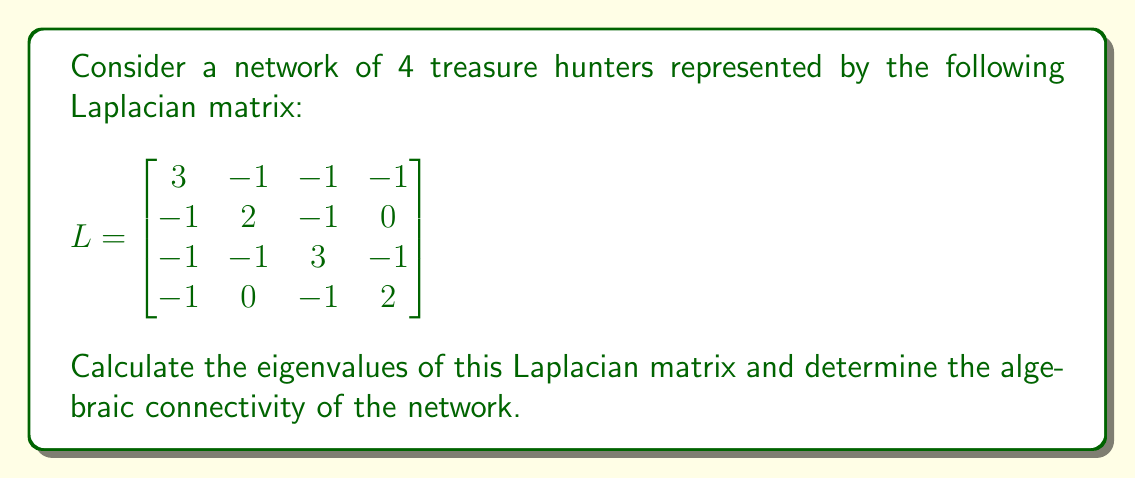Provide a solution to this math problem. 1) To find the eigenvalues, we need to solve the characteristic equation:
   $$\det(L - \lambda I) = 0$$

2) Expanding the determinant:
   $$\begin{vmatrix}
   3-\lambda & -1 & -1 & -1 \\
   -1 & 2-\lambda & -1 & 0 \\
   -1 & -1 & 3-\lambda & -1 \\
   -1 & 0 & -1 & 2-\lambda
   \end{vmatrix} = 0$$

3) This yields the characteristic polynomial:
   $$\lambda^4 - 10\lambda^3 + 31\lambda^2 - 30\lambda = 0$$

4) Factoring out $\lambda$:
   $$\lambda(\lambda^3 - 10\lambda^2 + 31\lambda - 30) = 0$$

5) The roots of this equation are the eigenvalues. We can see that $\lambda_1 = 0$ is always an eigenvalue of a Laplacian matrix.

6) The remaining cubic equation can be factored:
   $$\lambda(\lambda - 1)(\lambda - 4)(\lambda - 5) = 0$$

7) Therefore, the eigenvalues are:
   $$\lambda_1 = 0, \lambda_2 = 1, \lambda_3 = 4, \lambda_4 = 5$$

8) The algebraic connectivity is defined as the second smallest eigenvalue of the Laplacian matrix.

9) In this case, the algebraic connectivity is $\lambda_2 = 1$.
Answer: Eigenvalues: 0, 1, 4, 5; Algebraic connectivity: 1 